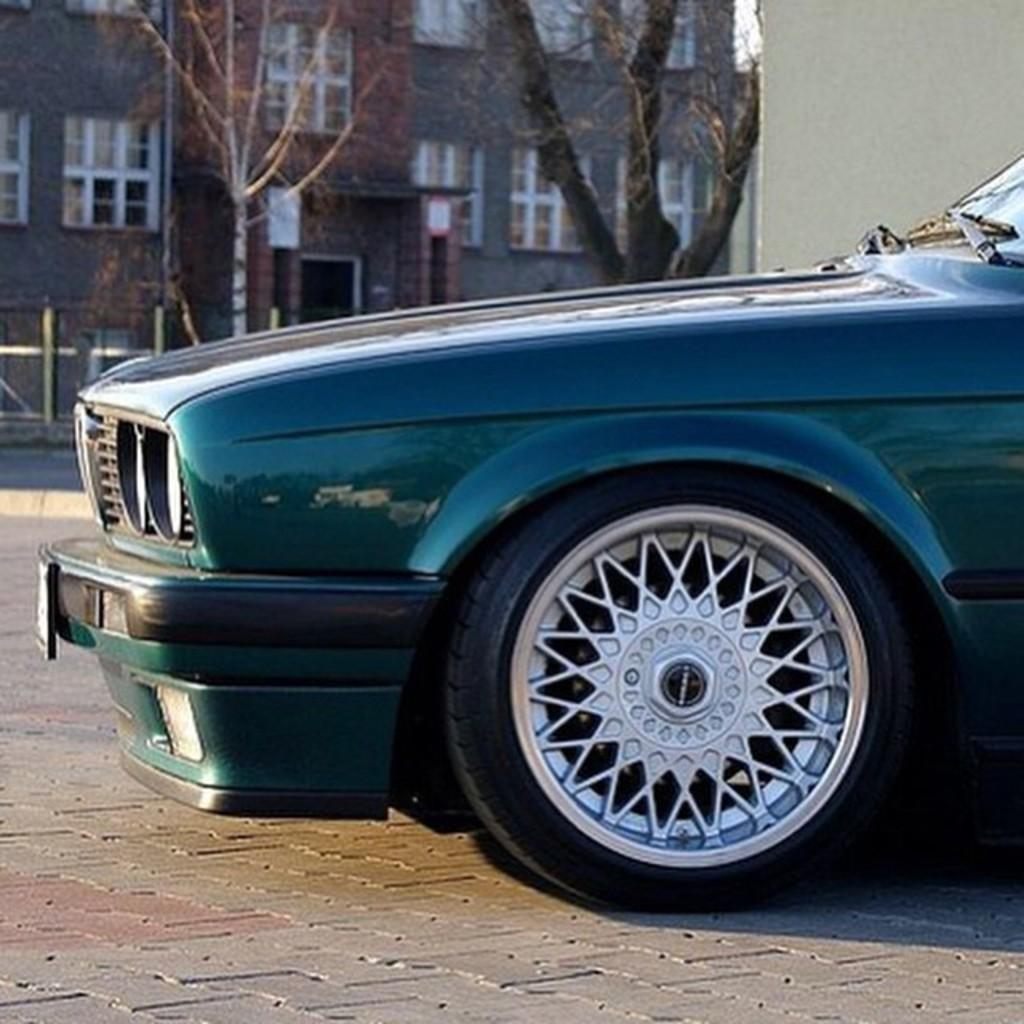What is the main subject of the image? The main subject of the image is a car. Where is the car located in the image? The car is on the road in the image. What can be seen in the background of the image? There are trees and a building in the background of the image. What discovery did the brothers make in the image? There is no mention of brothers or any discovery in the image. The image only features a car on the road with trees and a building in the background. 